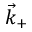<formula> <loc_0><loc_0><loc_500><loc_500>\vec { k } _ { + }</formula> 